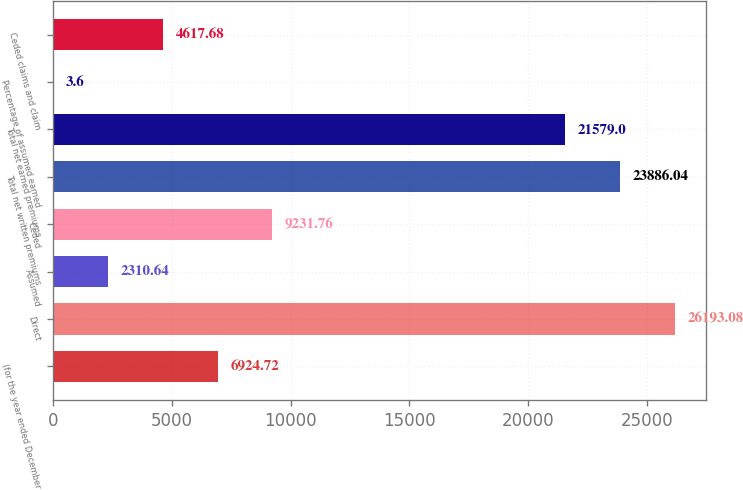Convert chart to OTSL. <chart><loc_0><loc_0><loc_500><loc_500><bar_chart><fcel>(for the year ended December<fcel>Direct<fcel>Assumed<fcel>Ceded<fcel>Total net written premiums<fcel>Total net earned premiums<fcel>Percentage of assumed earned<fcel>Ceded claims and claim<nl><fcel>6924.72<fcel>26193.1<fcel>2310.64<fcel>9231.76<fcel>23886<fcel>21579<fcel>3.6<fcel>4617.68<nl></chart> 